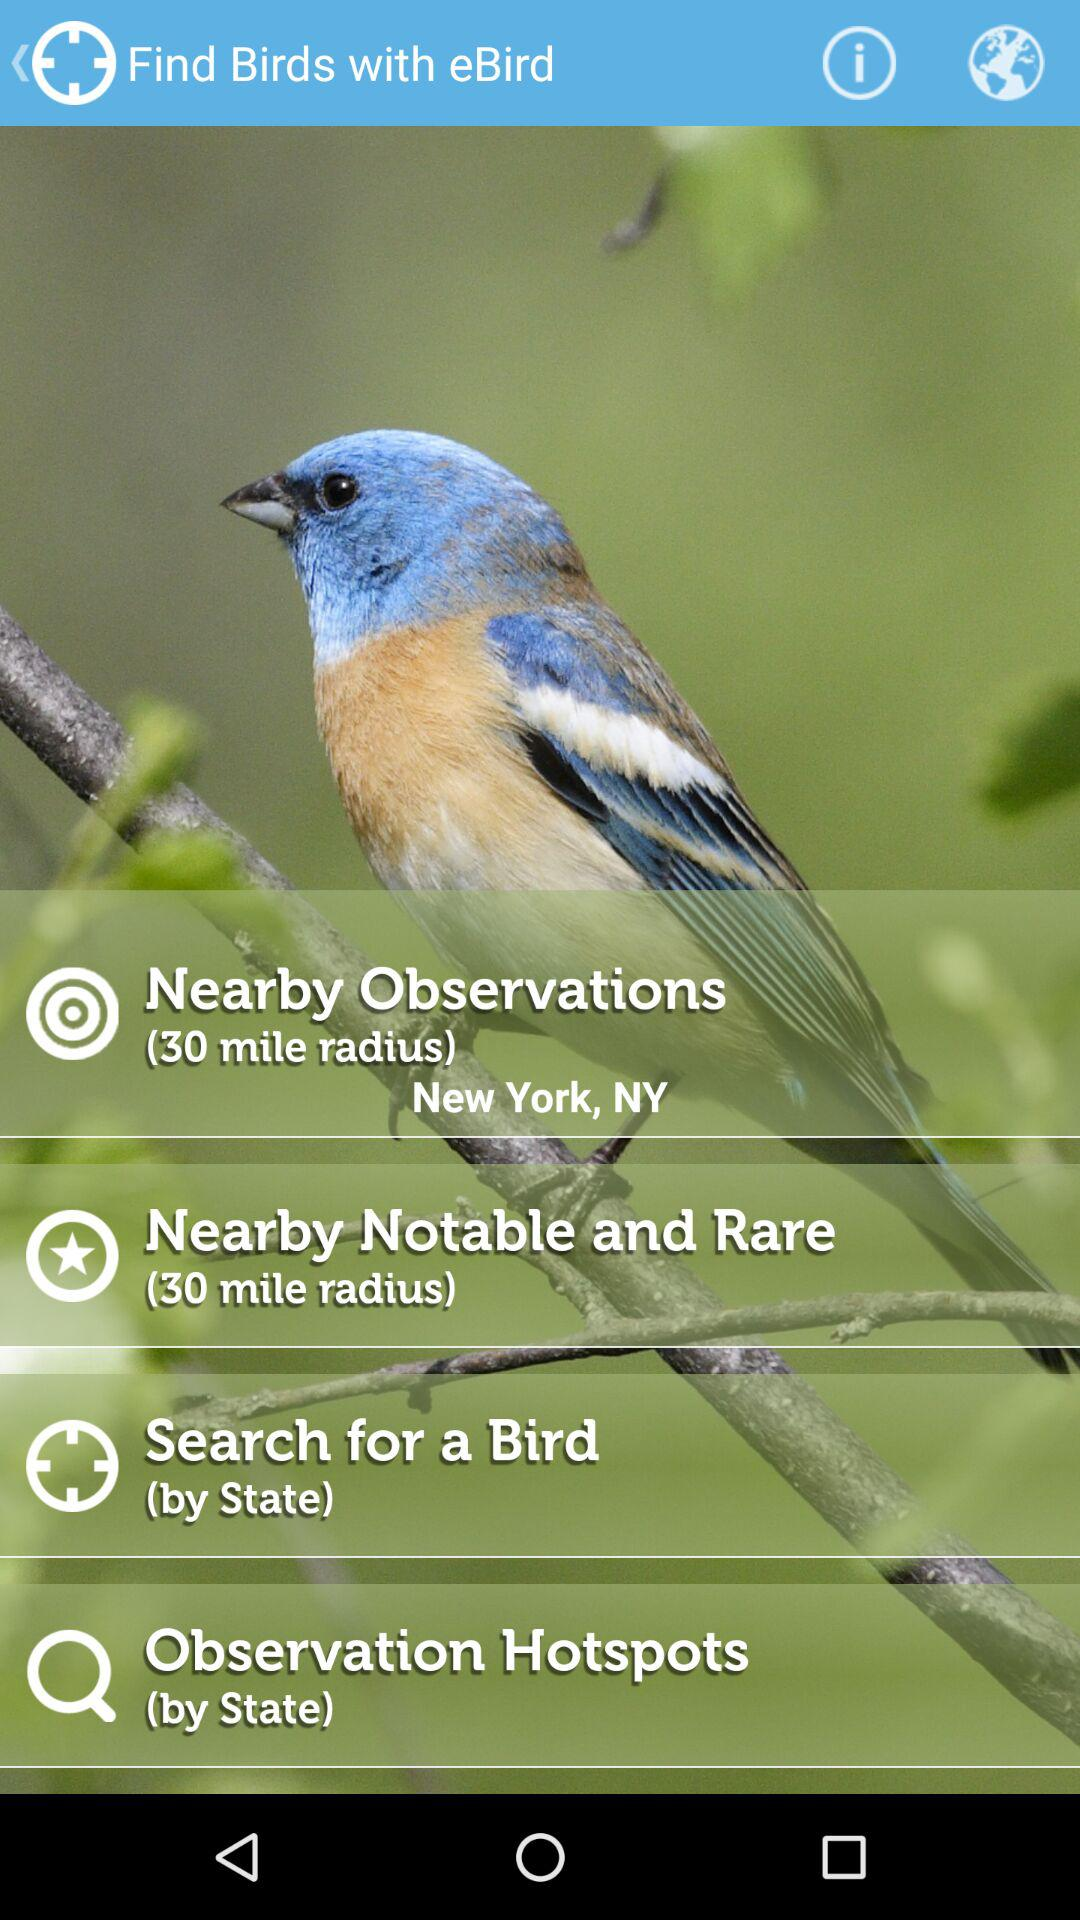What is the radius for nearby observations? The radius is 30 miles. 